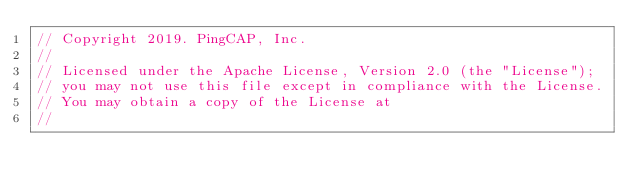<code> <loc_0><loc_0><loc_500><loc_500><_Go_>// Copyright 2019. PingCAP, Inc.
//
// Licensed under the Apache License, Version 2.0 (the "License");
// you may not use this file except in compliance with the License.
// You may obtain a copy of the License at
//</code> 